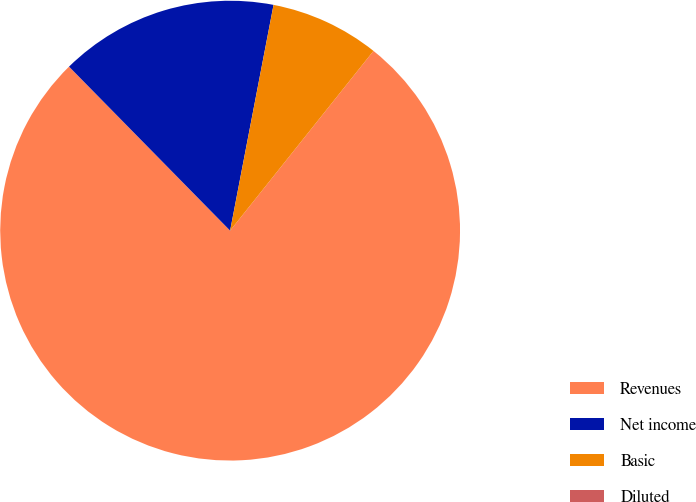Convert chart to OTSL. <chart><loc_0><loc_0><loc_500><loc_500><pie_chart><fcel>Revenues<fcel>Net income<fcel>Basic<fcel>Diluted<nl><fcel>76.92%<fcel>15.38%<fcel>7.69%<fcel>0.0%<nl></chart> 